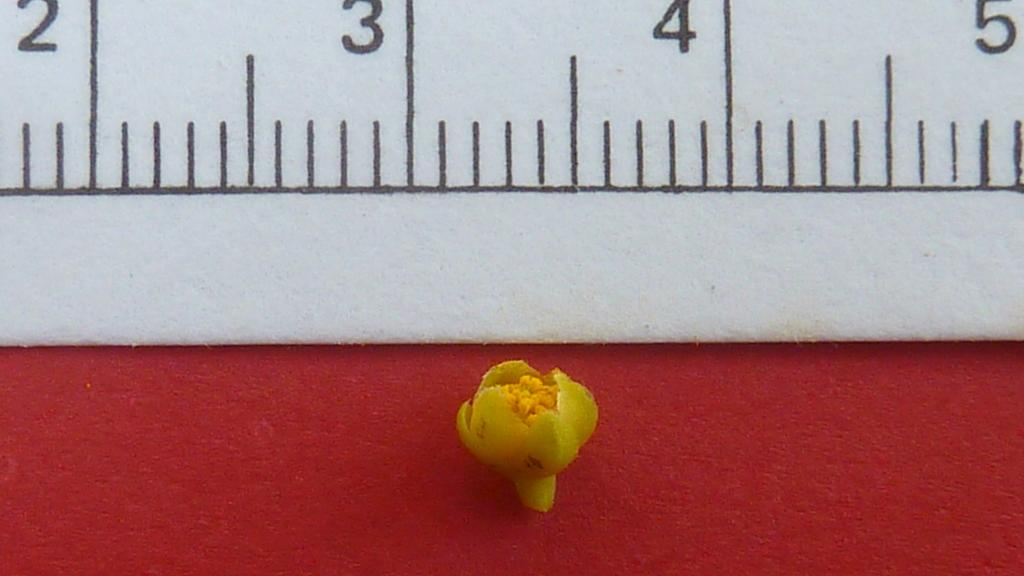<image>
Render a clear and concise summary of the photo. The number shown on the ruler are 2, 3, 4, and 5 